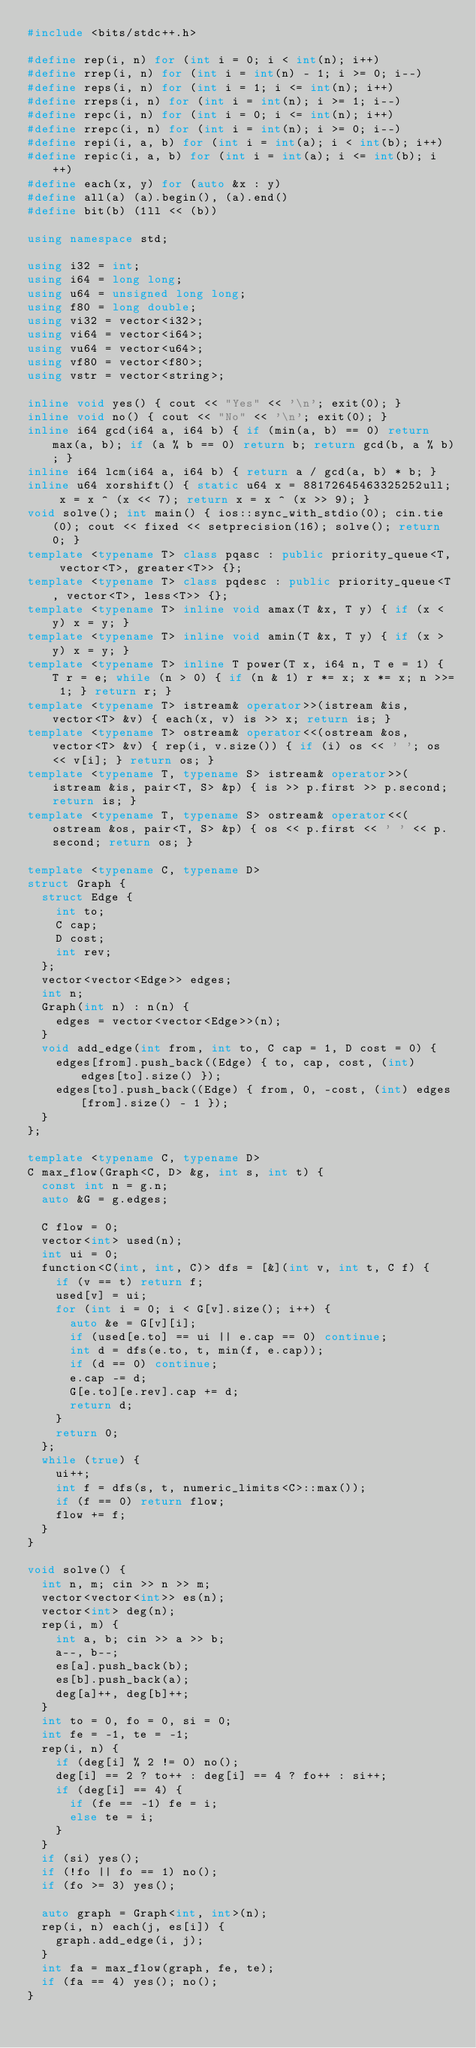<code> <loc_0><loc_0><loc_500><loc_500><_C++_>#include <bits/stdc++.h>

#define rep(i, n) for (int i = 0; i < int(n); i++)
#define rrep(i, n) for (int i = int(n) - 1; i >= 0; i--)
#define reps(i, n) for (int i = 1; i <= int(n); i++)
#define rreps(i, n) for (int i = int(n); i >= 1; i--)
#define repc(i, n) for (int i = 0; i <= int(n); i++)
#define rrepc(i, n) for (int i = int(n); i >= 0; i--)
#define repi(i, a, b) for (int i = int(a); i < int(b); i++)
#define repic(i, a, b) for (int i = int(a); i <= int(b); i++)
#define each(x, y) for (auto &x : y)
#define all(a) (a).begin(), (a).end()
#define bit(b) (1ll << (b))

using namespace std;

using i32 = int;
using i64 = long long;
using u64 = unsigned long long;
using f80 = long double;
using vi32 = vector<i32>;
using vi64 = vector<i64>;
using vu64 = vector<u64>;
using vf80 = vector<f80>;
using vstr = vector<string>;

inline void yes() { cout << "Yes" << '\n'; exit(0); }
inline void no() { cout << "No" << '\n'; exit(0); }
inline i64 gcd(i64 a, i64 b) { if (min(a, b) == 0) return max(a, b); if (a % b == 0) return b; return gcd(b, a % b); }
inline i64 lcm(i64 a, i64 b) { return a / gcd(a, b) * b; }
inline u64 xorshift() { static u64 x = 88172645463325252ull; x = x ^ (x << 7); return x = x ^ (x >> 9); }
void solve(); int main() { ios::sync_with_stdio(0); cin.tie(0); cout << fixed << setprecision(16); solve(); return 0; }
template <typename T> class pqasc : public priority_queue<T, vector<T>, greater<T>> {};
template <typename T> class pqdesc : public priority_queue<T, vector<T>, less<T>> {};
template <typename T> inline void amax(T &x, T y) { if (x < y) x = y; }
template <typename T> inline void amin(T &x, T y) { if (x > y) x = y; }
template <typename T> inline T power(T x, i64 n, T e = 1) { T r = e; while (n > 0) { if (n & 1) r *= x; x *= x; n >>= 1; } return r; }
template <typename T> istream& operator>>(istream &is, vector<T> &v) { each(x, v) is >> x; return is; }
template <typename T> ostream& operator<<(ostream &os, vector<T> &v) { rep(i, v.size()) { if (i) os << ' '; os << v[i]; } return os; }
template <typename T, typename S> istream& operator>>(istream &is, pair<T, S> &p) { is >> p.first >> p.second; return is; }
template <typename T, typename S> ostream& operator<<(ostream &os, pair<T, S> &p) { os << p.first << ' ' << p.second; return os; }

template <typename C, typename D>
struct Graph {
  struct Edge {
    int to;
    C cap;
    D cost;
    int rev;
  };
  vector<vector<Edge>> edges;
  int n;
  Graph(int n) : n(n) {
    edges = vector<vector<Edge>>(n);
  }
  void add_edge(int from, int to, C cap = 1, D cost = 0) {
    edges[from].push_back((Edge) { to, cap, cost, (int) edges[to].size() });
    edges[to].push_back((Edge) { from, 0, -cost, (int) edges[from].size() - 1 });
  }
};

template <typename C, typename D>
C max_flow(Graph<C, D> &g, int s, int t) {
  const int n = g.n;
  auto &G = g.edges;

  C flow = 0;
  vector<int> used(n);
  int ui = 0;
  function<C(int, int, C)> dfs = [&](int v, int t, C f) {
    if (v == t) return f;
    used[v] = ui;
    for (int i = 0; i < G[v].size(); i++) {
      auto &e = G[v][i];
      if (used[e.to] == ui || e.cap == 0) continue;
      int d = dfs(e.to, t, min(f, e.cap));
      if (d == 0) continue;
      e.cap -= d;
      G[e.to][e.rev].cap += d;
      return d;
    }
    return 0;
  };
  while (true) {
    ui++;
    int f = dfs(s, t, numeric_limits<C>::max());
    if (f == 0) return flow;
    flow += f;
  }
}

void solve() {
  int n, m; cin >> n >> m;
  vector<vector<int>> es(n);
  vector<int> deg(n);
  rep(i, m) {
    int a, b; cin >> a >> b;
    a--, b--;
    es[a].push_back(b);
    es[b].push_back(a);
    deg[a]++, deg[b]++;
  }
  int to = 0, fo = 0, si = 0;
  int fe = -1, te = -1;
  rep(i, n) {
    if (deg[i] % 2 != 0) no();
    deg[i] == 2 ? to++ : deg[i] == 4 ? fo++ : si++;
    if (deg[i] == 4) {
      if (fe == -1) fe = i;
      else te = i;
    }
  }
  if (si) yes();
  if (!fo || fo == 1) no();
  if (fo >= 3) yes();

  auto graph = Graph<int, int>(n);
  rep(i, n) each(j, es[i]) {
    graph.add_edge(i, j);
  }
  int fa = max_flow(graph, fe, te);
  if (fa == 4) yes(); no();
}
</code> 